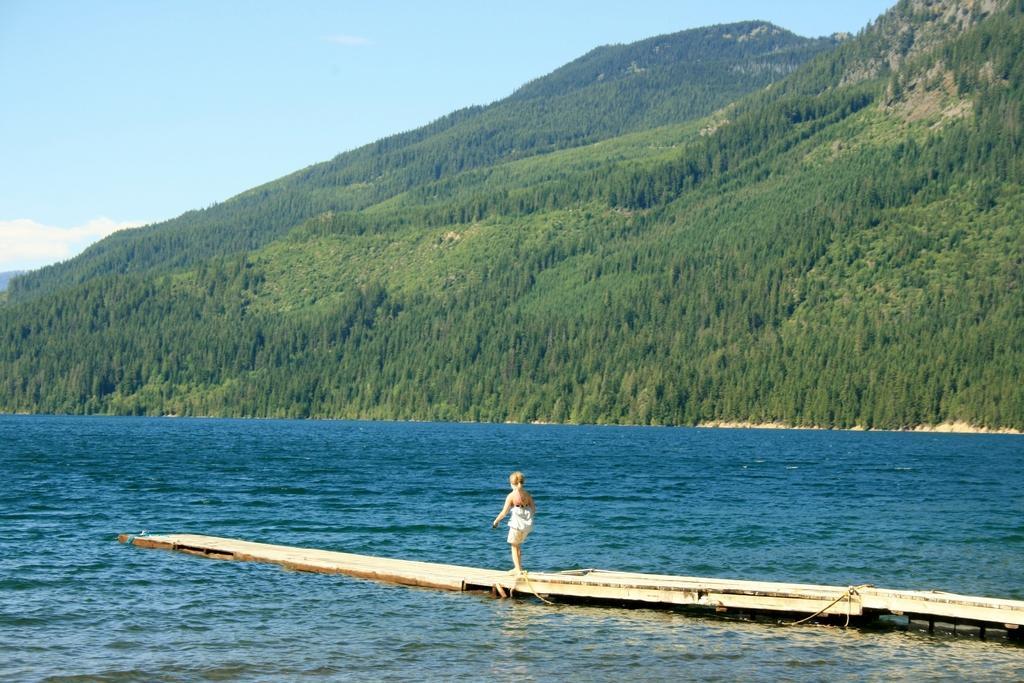In one or two sentences, can you explain what this image depicts? At the bottom of this image, there is a child standing on a wooden platform, which is on a water. In the background, there are mountains and there are clouds in the blue sky. 